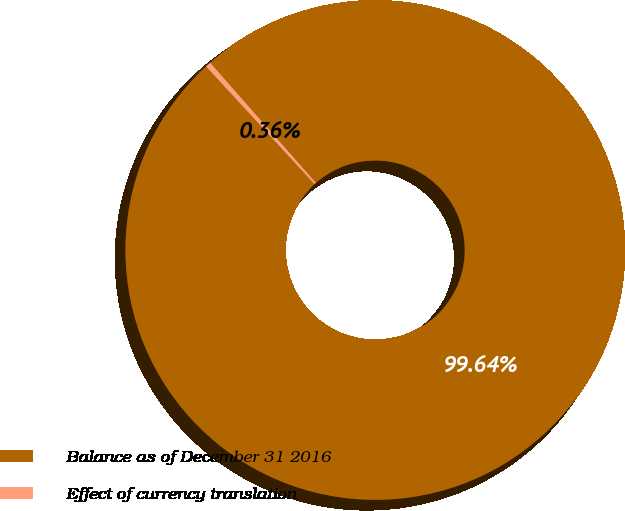Convert chart to OTSL. <chart><loc_0><loc_0><loc_500><loc_500><pie_chart><fcel>Balance as of December 31 2016<fcel>Effect of currency translation<nl><fcel>99.64%<fcel>0.36%<nl></chart> 